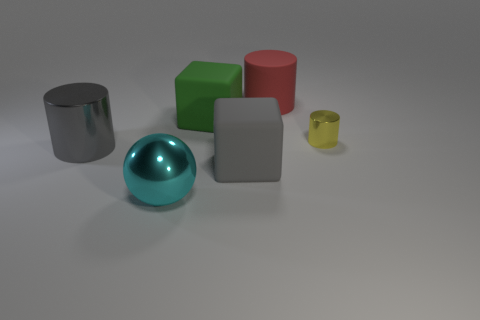Add 3 large cyan metal things. How many objects exist? 9 Subtract all cubes. How many objects are left? 4 Subtract 1 yellow cylinders. How many objects are left? 5 Subtract all gray matte things. Subtract all yellow cylinders. How many objects are left? 4 Add 6 yellow cylinders. How many yellow cylinders are left? 7 Add 4 yellow shiny things. How many yellow shiny things exist? 5 